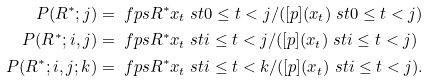Convert formula to latex. <formula><loc_0><loc_0><loc_500><loc_500>P ( R ^ { * } ; j ) & = \ f p s { R ^ { * } } { x _ { t } \ s t 0 \leq t < j } / ( [ p ] ( x _ { t } ) \ s t 0 \leq t < j ) \\ P ( R ^ { * } ; i , j ) & = \ f p s { R ^ { * } } { x _ { t } \ s t i \leq t < j } / ( [ p ] ( x _ { t } ) \ s t i \leq t < j ) \\ P ( R ^ { * } ; i , j ; k ) & = \ f p s { R ^ { * } } { x _ { t } \ s t i \leq t < k } / ( [ p ] ( x _ { t } ) \ s t i \leq t < j ) .</formula> 